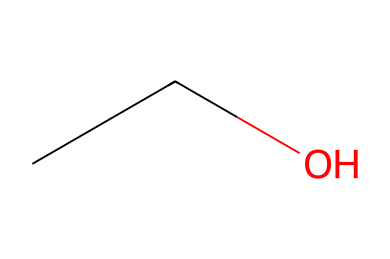What is the name of this chemical? The SMILES representation "CCO" corresponds to ethanol, which is a common name for ethyl alcohol.
Answer: ethanol How many carbon atoms are present in ethanol? The SMILES notation indicates two carbon (C) atoms in the sequence "CC".
Answer: 2 How many hydrogen atoms are bonded in total in ethanol? Ethanol has the formula C2H6O, which accounts for six hydrogen (H) atoms.
Answer: 6 What type of bond connects the carbon and oxygen in ethanol? The structure can be analyzed where carbon is connected to oxygen through a single bond.
Answer: single bond What functional group is present in ethanol that makes it a flammable liquid? Ethanol contains a hydroxyl (-OH) functional group, which classifies it as an alcohol, contributing to its flammability.
Answer: hydroxyl Is ethanol classified as a primary, secondary, or tertiary alcohol? Ethanol has the hydroxyl group attached to the terminal carbon, making it a primary alcohol.
Answer: primary What is the molecular formula of ethanol? Analyzing the atoms present from the SMILES yields the molecular formula C2H6O for ethanol.
Answer: C2H6O 